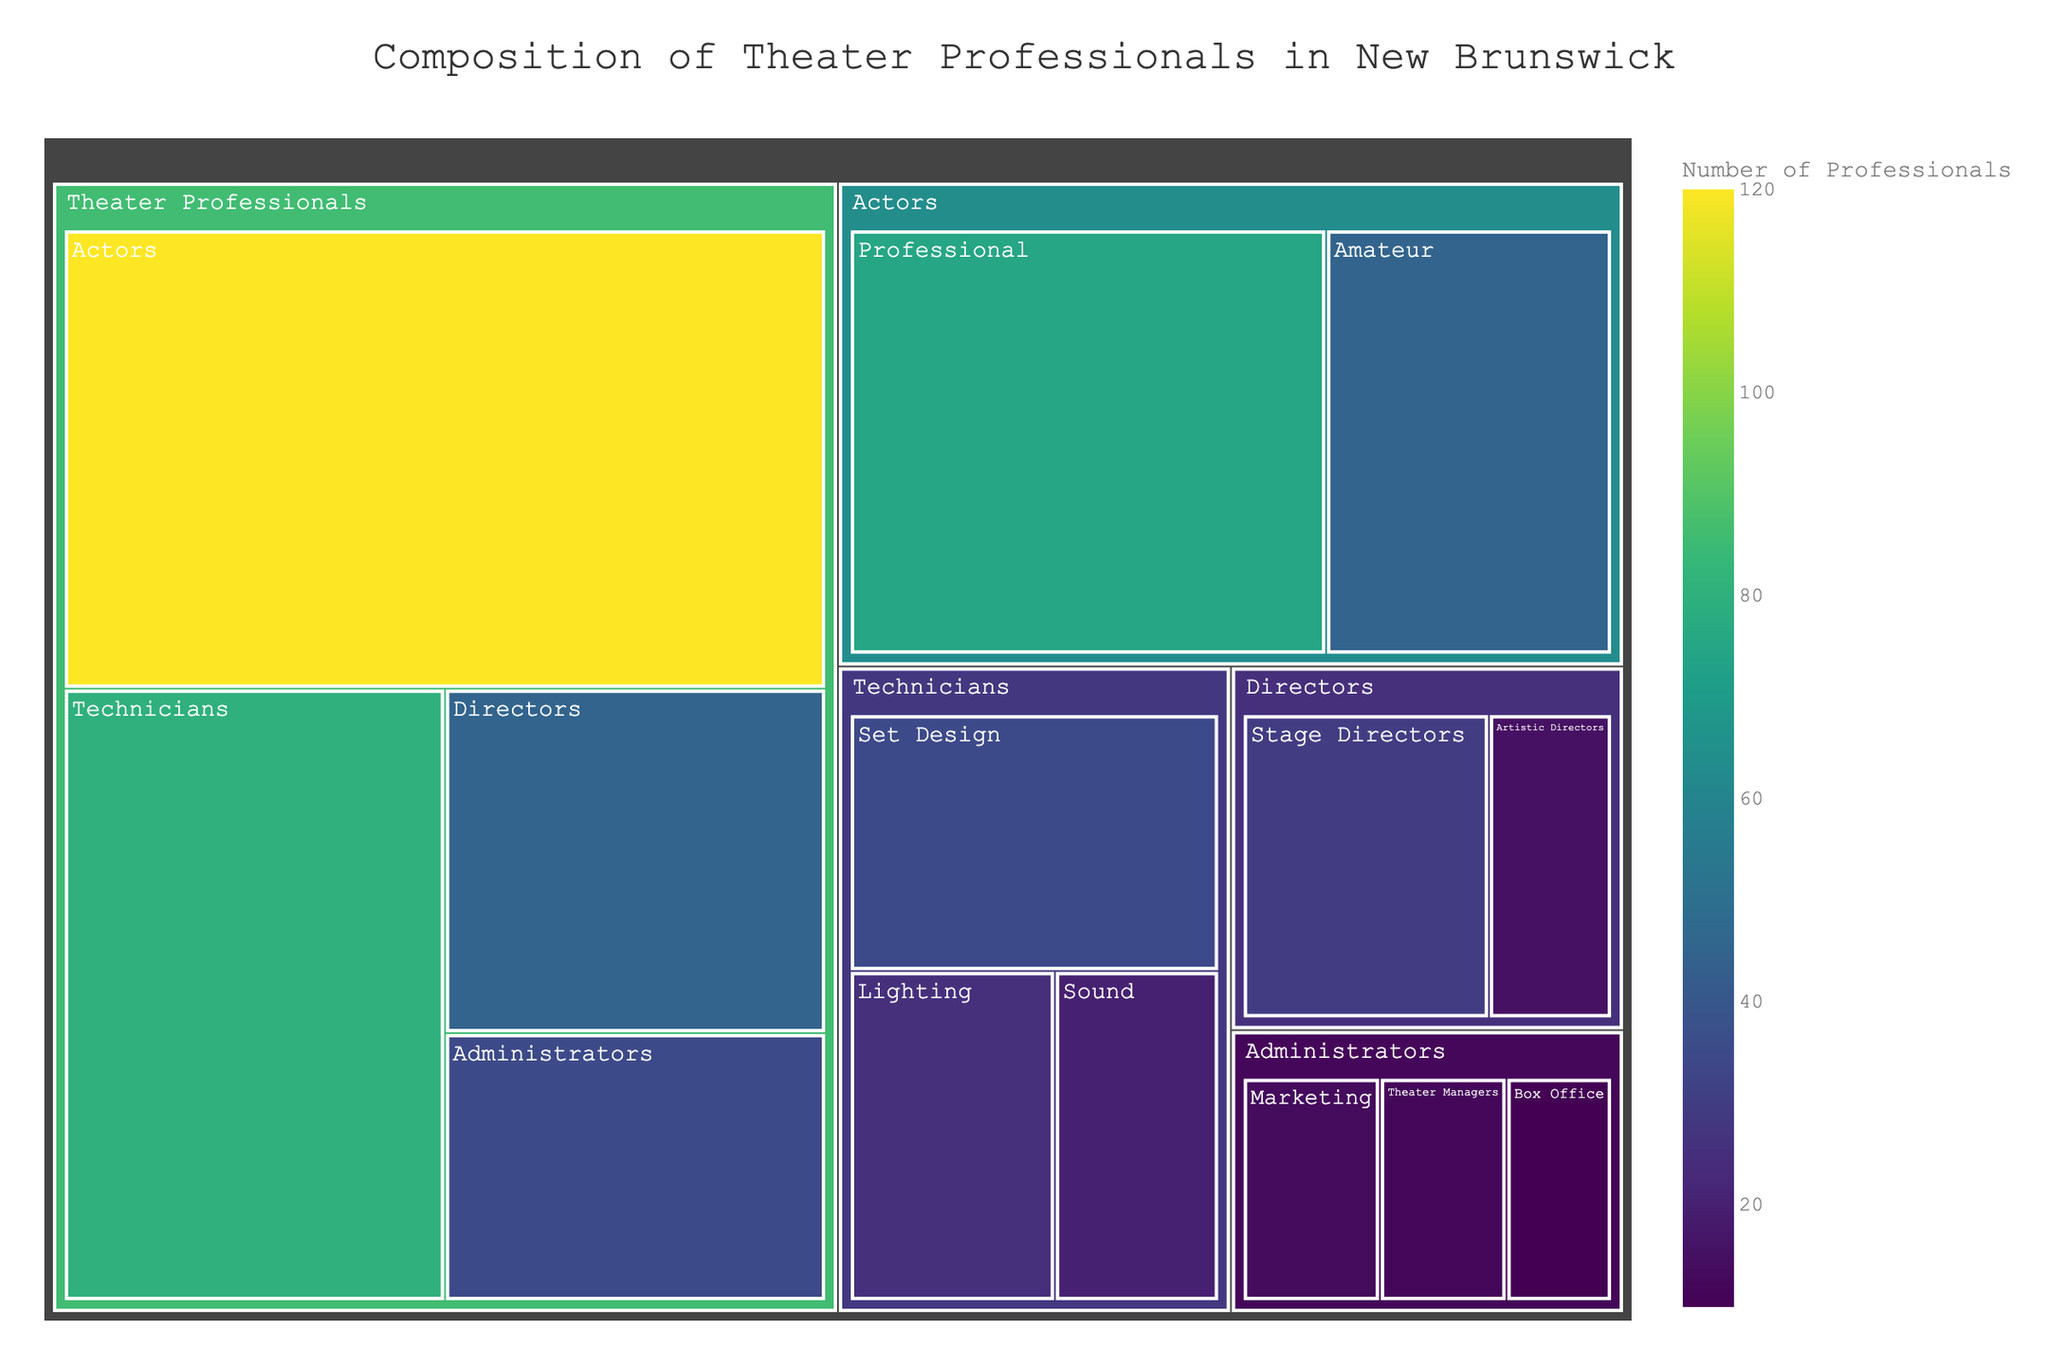what is the total number of theater professionals portrayed in the treemap? We need to sum the numbers of all professionals in the treemap: Actors (120), Directors (45), Technicians (80), Administrators (35). Total = 120 + 45 + 80 + 35
Answer: 280 How many more actors are there compared to directors? Subtract the number of directors (45) from the number of actors (120). 120 - 45 = 75
Answer: 75 Which category has the highest number of professionals? Compare the numbers given for each main category: Actors (120), Directors (45), Technicians (80), Administrators (35). The highest is Actors.
Answer: Actors What proportion of technicians specializes in sound? Calculate the proportion of sound technicians within all technicians: 20 (Sound) out of 80 (Technicians). The proportion is 20/80 = 0.25 or 25%
Answer: 25% How many more set designers are there than box office administrators? Subtract the number of box office administrators (10) from the set designers (35). 35 - 10 = 25
Answer: 25 What is the sum of amateur actors and stage directors? Add the number of amateur actors (45) and stage directors (30). 45 + 30 = 75
Answer: 75 Which role within administrators has the lowest number? Compare the numbers within the administrators category: Theater Managers (12), Marketing (13), Box Office (10). The lowest is Box Office.
Answer: Box Office What is the percentage of artistic directors within the directors category? Calculate the percentage: 15 (Artistic Directors) out of 45 (Directors). The percentage is (15/45) * 100 ≈ 33.33%
Answer: 33.33% Is the number of amateur actors greater than the number of sound technicians? Compare the numbers: 45 (Amateur Actors) and 20 (Sound Technicians). Yes, 45 is greater than 20.
Answer: Yes Which main category has the smallest representation? Compare the total numbers for each main category: Actors (120), Directors (45), Technicians (80), Administrators (35). The smallest is Administrators.
Answer: Administrators 